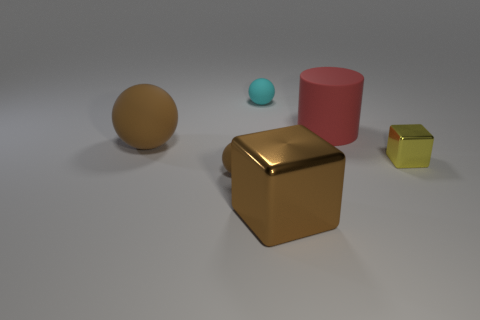What is the size of the other sphere that is the same color as the large sphere?
Your response must be concise. Small. Are there an equal number of tiny yellow metal objects on the left side of the large brown rubber sphere and large brown matte objects that are right of the tiny cyan object?
Offer a terse response. Yes. What color is the thing right of the large red thing?
Give a very brief answer. Yellow. There is a big block; does it have the same color as the small rubber thing in front of the small metallic block?
Give a very brief answer. Yes. Is the number of large red matte cylinders less than the number of small brown metallic spheres?
Your answer should be compact. No. Do the small rubber ball that is in front of the small cyan rubber ball and the cylinder have the same color?
Keep it short and to the point. No. What number of brown shiny blocks have the same size as the red matte thing?
Make the answer very short. 1. Is there a small block of the same color as the big shiny object?
Your response must be concise. No. Is the big red cylinder made of the same material as the tiny cyan object?
Your answer should be compact. Yes. What number of big shiny objects are the same shape as the small metal object?
Your response must be concise. 1. 